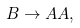<formula> <loc_0><loc_0><loc_500><loc_500>B \rightarrow A A ,</formula> 